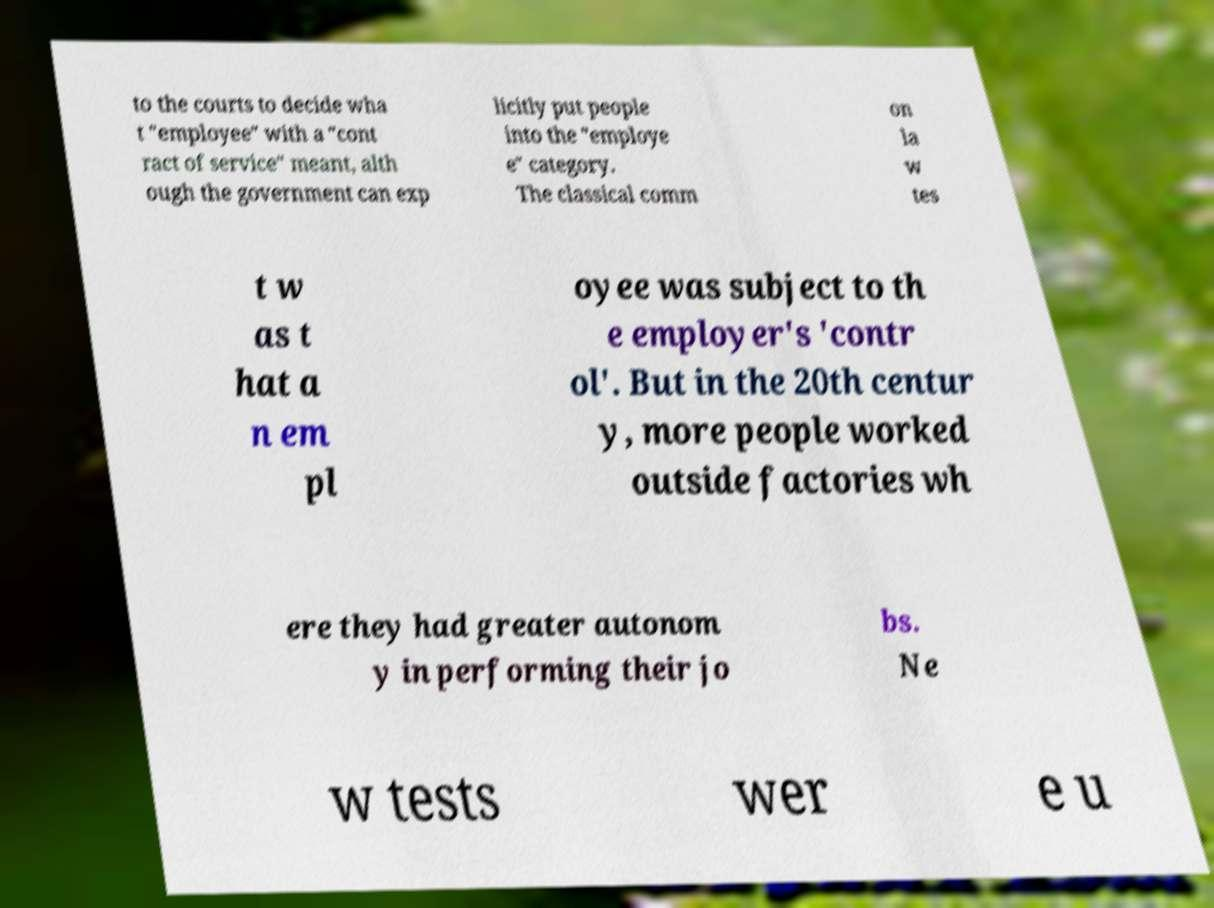I need the written content from this picture converted into text. Can you do that? to the courts to decide wha t "employee" with a "cont ract of service" meant, alth ough the government can exp licitly put people into the "employe e" category. The classical comm on la w tes t w as t hat a n em pl oyee was subject to th e employer's 'contr ol'. But in the 20th centur y, more people worked outside factories wh ere they had greater autonom y in performing their jo bs. Ne w tests wer e u 